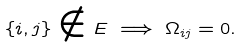<formula> <loc_0><loc_0><loc_500><loc_500>\left \{ i , j \right \} \notin E \implies \Omega _ { i j } = 0 .</formula> 